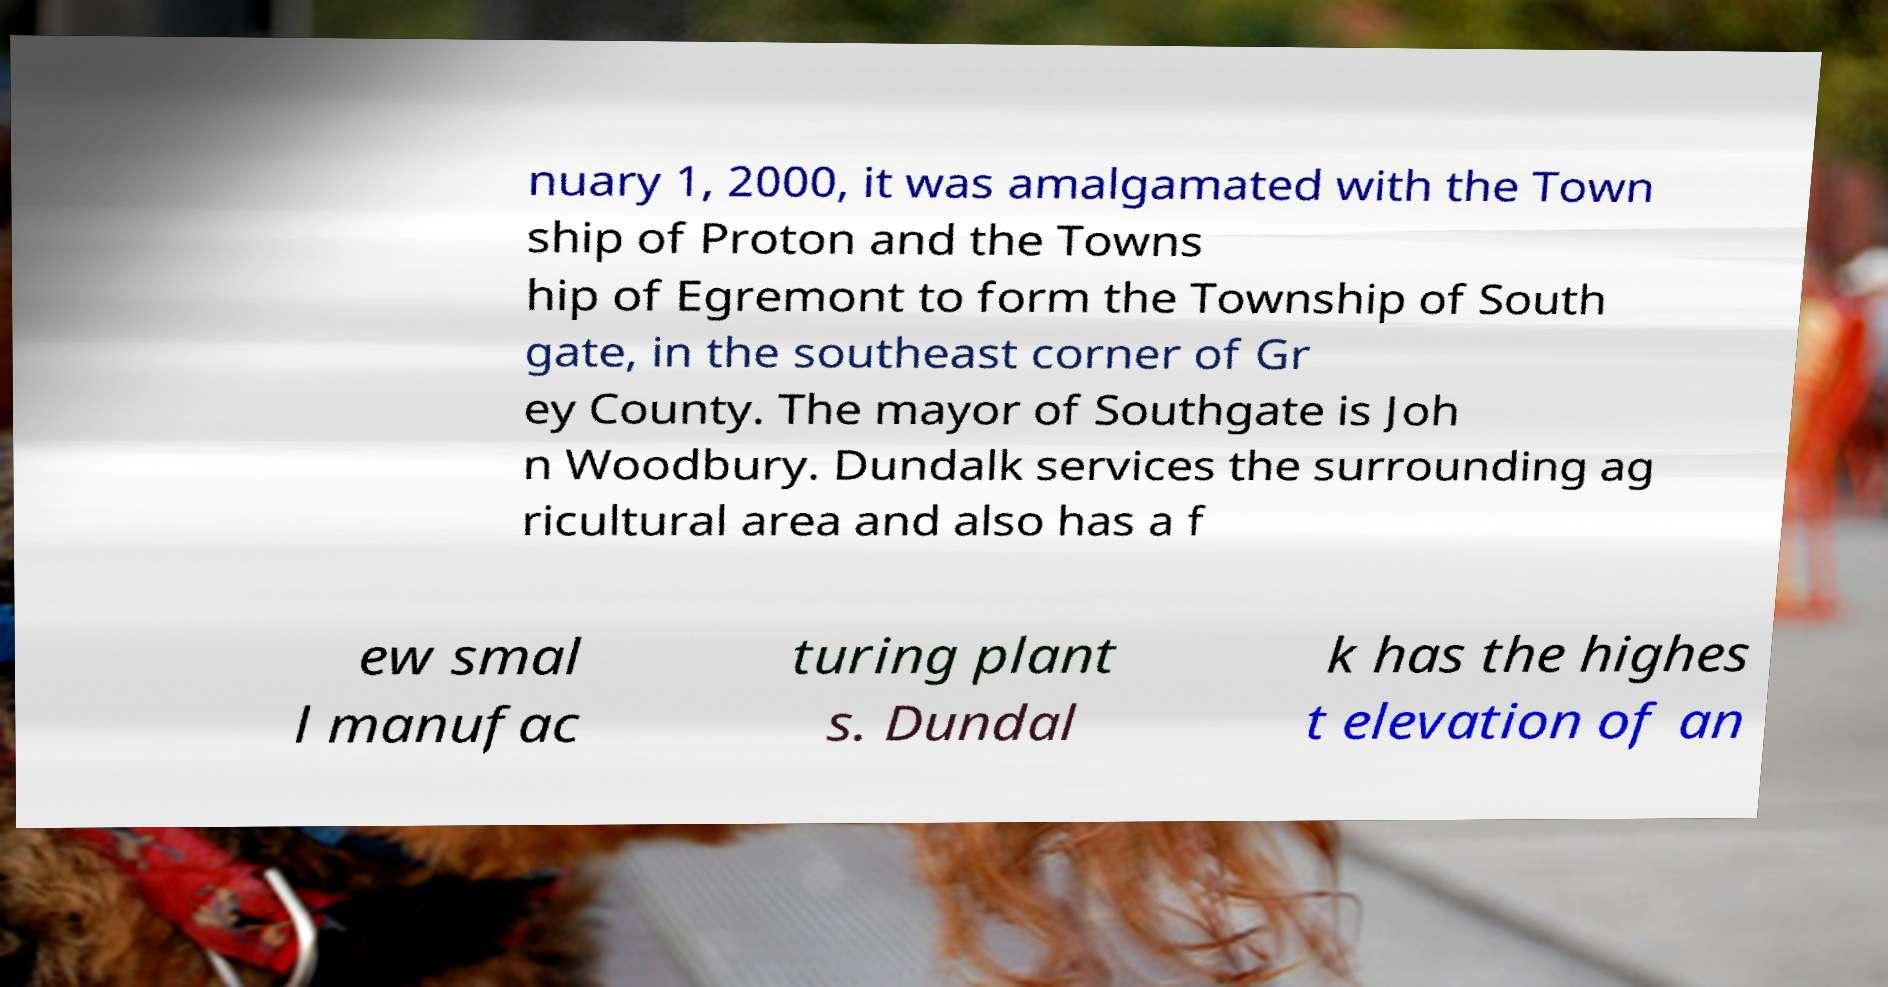What messages or text are displayed in this image? I need them in a readable, typed format. nuary 1, 2000, it was amalgamated with the Town ship of Proton and the Towns hip of Egremont to form the Township of South gate, in the southeast corner of Gr ey County. The mayor of Southgate is Joh n Woodbury. Dundalk services the surrounding ag ricultural area and also has a f ew smal l manufac turing plant s. Dundal k has the highes t elevation of an 